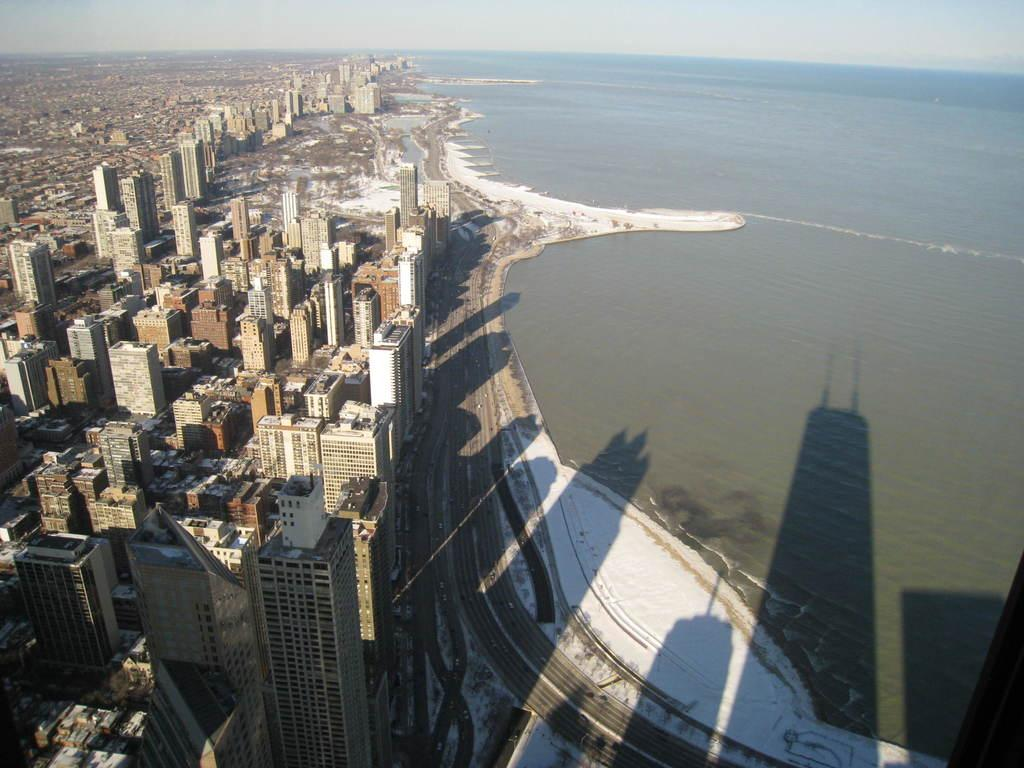What type of structures can be seen in the image? There are buildings in the image. What else is present in the image besides the buildings? There is a road and water visible on the right side of the image. What part of the natural environment is visible in the image? The sky is visible in the image. What type of screw can be seen in the yard in the image? There is no screw or yard present in the image. 